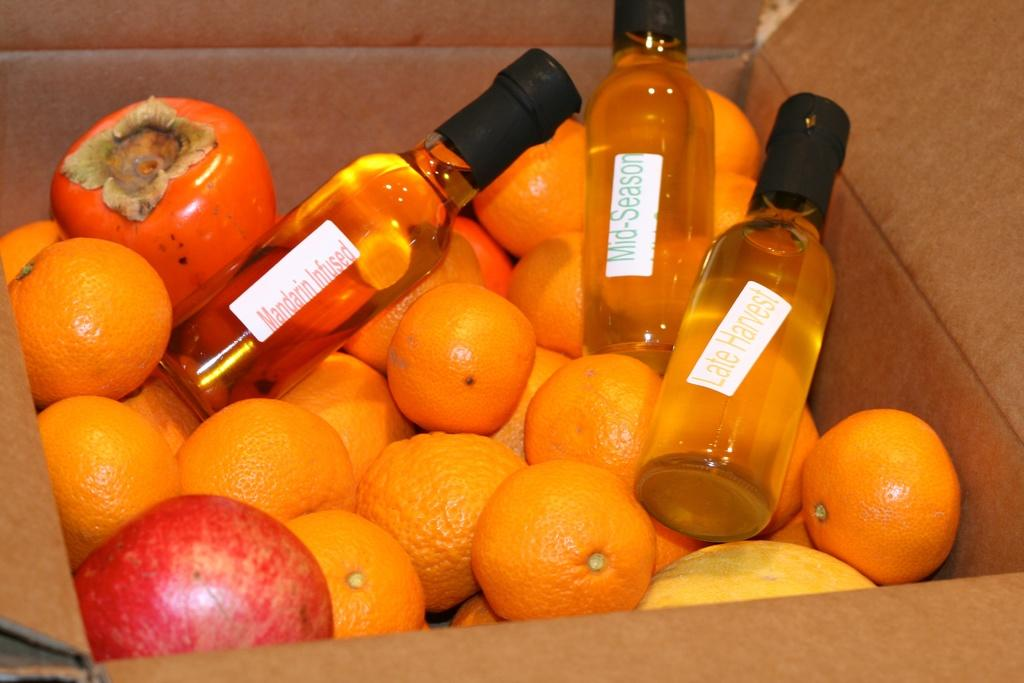What is the main object in the image? There is a cardboard box in the image. What is inside the box? The box contains many oranges and a few pomegranates. Are there any other items in the box besides fruits? Yes, there are three bottles with labels in the box. How does the iron help in the amusement of the oranges in the image? There is no iron or amusement present in the image; it only features a cardboard box containing oranges, pomegranates, and bottles. 